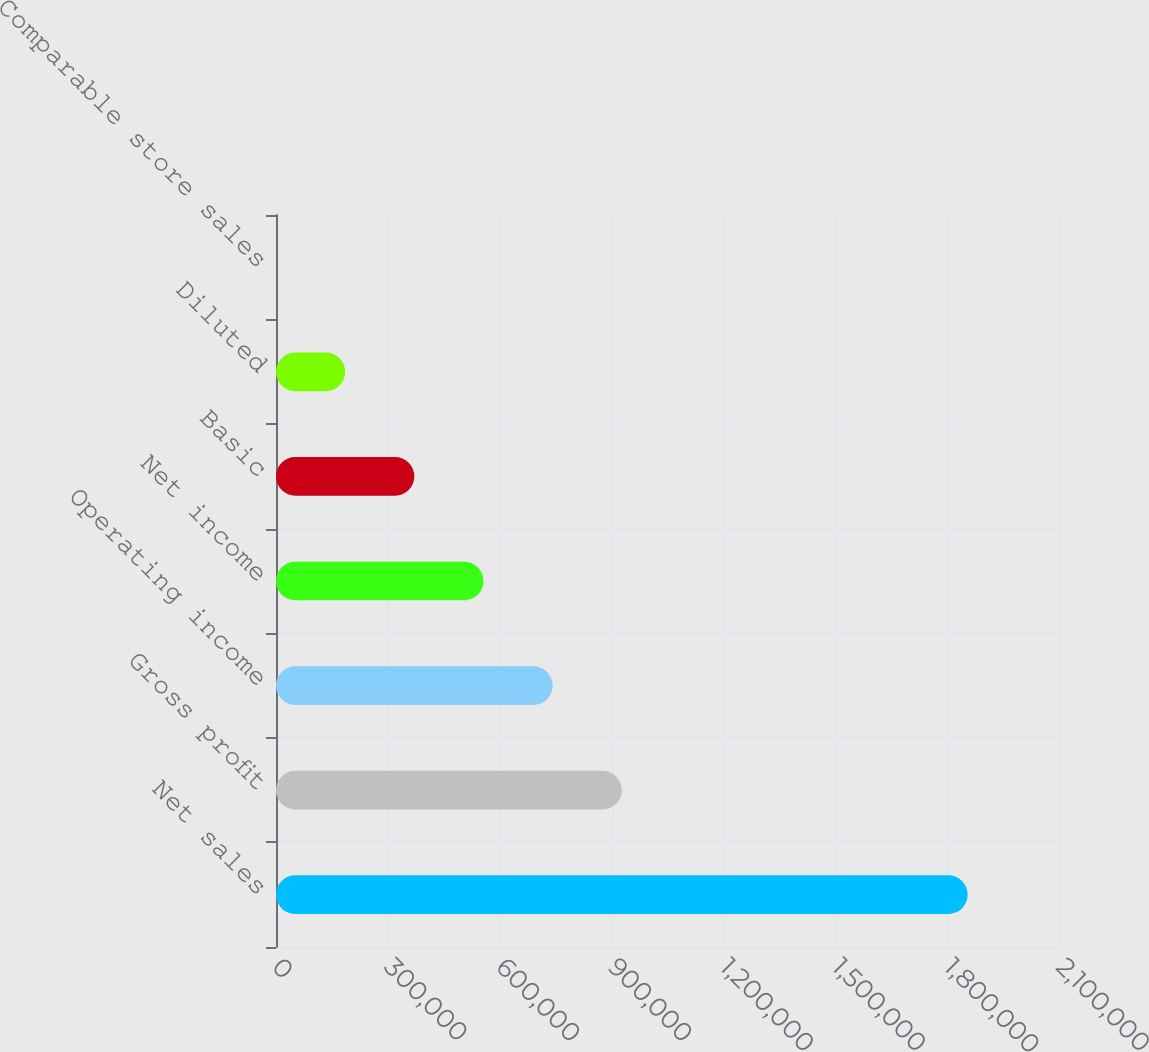Convert chart. <chart><loc_0><loc_0><loc_500><loc_500><bar_chart><fcel>Net sales<fcel>Gross profit<fcel>Operating income<fcel>Net income<fcel>Basic<fcel>Diluted<fcel>Comparable store sales<nl><fcel>1.85253e+06<fcel>926267<fcel>741014<fcel>555761<fcel>370507<fcel>185254<fcel>0.5<nl></chart> 